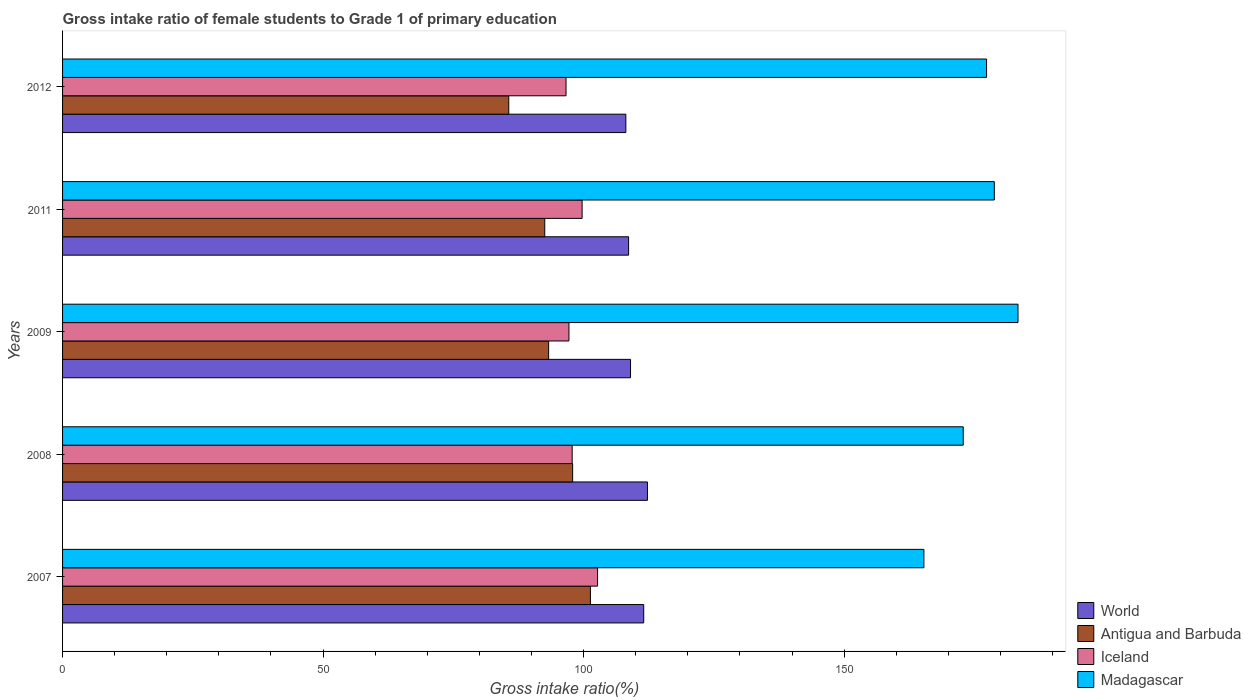How many different coloured bars are there?
Your answer should be very brief. 4. Are the number of bars on each tick of the Y-axis equal?
Make the answer very short. Yes. What is the label of the 4th group of bars from the top?
Your answer should be very brief. 2008. What is the gross intake ratio in World in 2008?
Make the answer very short. 112.26. Across all years, what is the maximum gross intake ratio in Antigua and Barbuda?
Make the answer very short. 101.31. Across all years, what is the minimum gross intake ratio in Antigua and Barbuda?
Keep it short and to the point. 85.64. In which year was the gross intake ratio in Antigua and Barbuda maximum?
Make the answer very short. 2007. In which year was the gross intake ratio in Antigua and Barbuda minimum?
Keep it short and to the point. 2012. What is the total gross intake ratio in World in the graph?
Your response must be concise. 549.55. What is the difference between the gross intake ratio in World in 2007 and that in 2012?
Your response must be concise. 3.43. What is the difference between the gross intake ratio in Antigua and Barbuda in 2009 and the gross intake ratio in Madagascar in 2012?
Your answer should be compact. -84.05. What is the average gross intake ratio in Antigua and Barbuda per year?
Offer a terse response. 94.14. In the year 2007, what is the difference between the gross intake ratio in Antigua and Barbuda and gross intake ratio in Madagascar?
Provide a short and direct response. -64.01. What is the ratio of the gross intake ratio in Madagascar in 2007 to that in 2008?
Your answer should be compact. 0.96. What is the difference between the highest and the second highest gross intake ratio in Antigua and Barbuda?
Your answer should be compact. 3.41. What is the difference between the highest and the lowest gross intake ratio in Madagascar?
Your response must be concise. 18.06. Is the sum of the gross intake ratio in Iceland in 2007 and 2009 greater than the maximum gross intake ratio in Antigua and Barbuda across all years?
Your response must be concise. Yes. Is it the case that in every year, the sum of the gross intake ratio in Antigua and Barbuda and gross intake ratio in Iceland is greater than the sum of gross intake ratio in World and gross intake ratio in Madagascar?
Your answer should be compact. No. What does the 1st bar from the bottom in 2007 represents?
Provide a succinct answer. World. Is it the case that in every year, the sum of the gross intake ratio in Antigua and Barbuda and gross intake ratio in Iceland is greater than the gross intake ratio in World?
Keep it short and to the point. Yes. How many bars are there?
Your response must be concise. 20. What is the difference between two consecutive major ticks on the X-axis?
Offer a very short reply. 50. Are the values on the major ticks of X-axis written in scientific E-notation?
Your answer should be compact. No. How are the legend labels stacked?
Provide a short and direct response. Vertical. What is the title of the graph?
Make the answer very short. Gross intake ratio of female students to Grade 1 of primary education. Does "Brazil" appear as one of the legend labels in the graph?
Your answer should be very brief. No. What is the label or title of the X-axis?
Offer a very short reply. Gross intake ratio(%). What is the Gross intake ratio(%) of World in 2007?
Provide a succinct answer. 111.54. What is the Gross intake ratio(%) of Antigua and Barbuda in 2007?
Offer a very short reply. 101.31. What is the Gross intake ratio(%) in Iceland in 2007?
Give a very brief answer. 102.68. What is the Gross intake ratio(%) of Madagascar in 2007?
Give a very brief answer. 165.32. What is the Gross intake ratio(%) of World in 2008?
Your answer should be compact. 112.26. What is the Gross intake ratio(%) of Antigua and Barbuda in 2008?
Your answer should be very brief. 97.9. What is the Gross intake ratio(%) of Iceland in 2008?
Your answer should be very brief. 97.81. What is the Gross intake ratio(%) in Madagascar in 2008?
Your answer should be compact. 172.86. What is the Gross intake ratio(%) of World in 2009?
Make the answer very short. 109.01. What is the Gross intake ratio(%) in Antigua and Barbuda in 2009?
Offer a terse response. 93.29. What is the Gross intake ratio(%) of Iceland in 2009?
Offer a very short reply. 97.19. What is the Gross intake ratio(%) in Madagascar in 2009?
Offer a very short reply. 183.37. What is the Gross intake ratio(%) of World in 2011?
Your answer should be compact. 108.64. What is the Gross intake ratio(%) in Antigua and Barbuda in 2011?
Ensure brevity in your answer.  92.54. What is the Gross intake ratio(%) in Iceland in 2011?
Your answer should be very brief. 99.71. What is the Gross intake ratio(%) of Madagascar in 2011?
Ensure brevity in your answer.  178.83. What is the Gross intake ratio(%) of World in 2012?
Ensure brevity in your answer.  108.11. What is the Gross intake ratio(%) of Antigua and Barbuda in 2012?
Provide a succinct answer. 85.64. What is the Gross intake ratio(%) in Iceland in 2012?
Ensure brevity in your answer.  96.63. What is the Gross intake ratio(%) of Madagascar in 2012?
Provide a succinct answer. 177.34. Across all years, what is the maximum Gross intake ratio(%) of World?
Provide a succinct answer. 112.26. Across all years, what is the maximum Gross intake ratio(%) of Antigua and Barbuda?
Provide a short and direct response. 101.31. Across all years, what is the maximum Gross intake ratio(%) in Iceland?
Provide a succinct answer. 102.68. Across all years, what is the maximum Gross intake ratio(%) of Madagascar?
Keep it short and to the point. 183.37. Across all years, what is the minimum Gross intake ratio(%) of World?
Your answer should be compact. 108.11. Across all years, what is the minimum Gross intake ratio(%) of Antigua and Barbuda?
Provide a succinct answer. 85.64. Across all years, what is the minimum Gross intake ratio(%) in Iceland?
Provide a succinct answer. 96.63. Across all years, what is the minimum Gross intake ratio(%) of Madagascar?
Give a very brief answer. 165.32. What is the total Gross intake ratio(%) in World in the graph?
Keep it short and to the point. 549.55. What is the total Gross intake ratio(%) in Antigua and Barbuda in the graph?
Give a very brief answer. 470.68. What is the total Gross intake ratio(%) of Iceland in the graph?
Give a very brief answer. 494.01. What is the total Gross intake ratio(%) of Madagascar in the graph?
Offer a very short reply. 877.72. What is the difference between the Gross intake ratio(%) in World in 2007 and that in 2008?
Your response must be concise. -0.72. What is the difference between the Gross intake ratio(%) in Antigua and Barbuda in 2007 and that in 2008?
Provide a succinct answer. 3.41. What is the difference between the Gross intake ratio(%) of Iceland in 2007 and that in 2008?
Give a very brief answer. 4.87. What is the difference between the Gross intake ratio(%) in Madagascar in 2007 and that in 2008?
Offer a very short reply. -7.55. What is the difference between the Gross intake ratio(%) in World in 2007 and that in 2009?
Provide a succinct answer. 2.53. What is the difference between the Gross intake ratio(%) in Antigua and Barbuda in 2007 and that in 2009?
Ensure brevity in your answer.  8.02. What is the difference between the Gross intake ratio(%) in Iceland in 2007 and that in 2009?
Give a very brief answer. 5.49. What is the difference between the Gross intake ratio(%) of Madagascar in 2007 and that in 2009?
Your response must be concise. -18.06. What is the difference between the Gross intake ratio(%) of World in 2007 and that in 2011?
Provide a short and direct response. 2.9. What is the difference between the Gross intake ratio(%) in Antigua and Barbuda in 2007 and that in 2011?
Offer a very short reply. 8.77. What is the difference between the Gross intake ratio(%) of Iceland in 2007 and that in 2011?
Your answer should be compact. 2.96. What is the difference between the Gross intake ratio(%) in Madagascar in 2007 and that in 2011?
Give a very brief answer. -13.51. What is the difference between the Gross intake ratio(%) in World in 2007 and that in 2012?
Your answer should be very brief. 3.43. What is the difference between the Gross intake ratio(%) in Antigua and Barbuda in 2007 and that in 2012?
Give a very brief answer. 15.67. What is the difference between the Gross intake ratio(%) in Iceland in 2007 and that in 2012?
Your answer should be compact. 6.05. What is the difference between the Gross intake ratio(%) of Madagascar in 2007 and that in 2012?
Make the answer very short. -12.02. What is the difference between the Gross intake ratio(%) of World in 2008 and that in 2009?
Keep it short and to the point. 3.25. What is the difference between the Gross intake ratio(%) in Antigua and Barbuda in 2008 and that in 2009?
Your response must be concise. 4.61. What is the difference between the Gross intake ratio(%) in Iceland in 2008 and that in 2009?
Your answer should be compact. 0.62. What is the difference between the Gross intake ratio(%) of Madagascar in 2008 and that in 2009?
Keep it short and to the point. -10.51. What is the difference between the Gross intake ratio(%) in World in 2008 and that in 2011?
Offer a terse response. 3.62. What is the difference between the Gross intake ratio(%) of Antigua and Barbuda in 2008 and that in 2011?
Your response must be concise. 5.35. What is the difference between the Gross intake ratio(%) in Iceland in 2008 and that in 2011?
Give a very brief answer. -1.91. What is the difference between the Gross intake ratio(%) of Madagascar in 2008 and that in 2011?
Offer a terse response. -5.96. What is the difference between the Gross intake ratio(%) of World in 2008 and that in 2012?
Ensure brevity in your answer.  4.15. What is the difference between the Gross intake ratio(%) of Antigua and Barbuda in 2008 and that in 2012?
Make the answer very short. 12.26. What is the difference between the Gross intake ratio(%) of Iceland in 2008 and that in 2012?
Your response must be concise. 1.18. What is the difference between the Gross intake ratio(%) of Madagascar in 2008 and that in 2012?
Offer a terse response. -4.48. What is the difference between the Gross intake ratio(%) of World in 2009 and that in 2011?
Make the answer very short. 0.37. What is the difference between the Gross intake ratio(%) in Antigua and Barbuda in 2009 and that in 2011?
Offer a very short reply. 0.75. What is the difference between the Gross intake ratio(%) of Iceland in 2009 and that in 2011?
Give a very brief answer. -2.53. What is the difference between the Gross intake ratio(%) in Madagascar in 2009 and that in 2011?
Ensure brevity in your answer.  4.55. What is the difference between the Gross intake ratio(%) in World in 2009 and that in 2012?
Ensure brevity in your answer.  0.9. What is the difference between the Gross intake ratio(%) in Antigua and Barbuda in 2009 and that in 2012?
Provide a succinct answer. 7.65. What is the difference between the Gross intake ratio(%) in Iceland in 2009 and that in 2012?
Provide a short and direct response. 0.56. What is the difference between the Gross intake ratio(%) in Madagascar in 2009 and that in 2012?
Ensure brevity in your answer.  6.03. What is the difference between the Gross intake ratio(%) of World in 2011 and that in 2012?
Provide a short and direct response. 0.53. What is the difference between the Gross intake ratio(%) in Antigua and Barbuda in 2011 and that in 2012?
Give a very brief answer. 6.91. What is the difference between the Gross intake ratio(%) in Iceland in 2011 and that in 2012?
Offer a very short reply. 3.09. What is the difference between the Gross intake ratio(%) in Madagascar in 2011 and that in 2012?
Provide a short and direct response. 1.49. What is the difference between the Gross intake ratio(%) of World in 2007 and the Gross intake ratio(%) of Antigua and Barbuda in 2008?
Provide a short and direct response. 13.64. What is the difference between the Gross intake ratio(%) in World in 2007 and the Gross intake ratio(%) in Iceland in 2008?
Keep it short and to the point. 13.73. What is the difference between the Gross intake ratio(%) of World in 2007 and the Gross intake ratio(%) of Madagascar in 2008?
Provide a succinct answer. -61.32. What is the difference between the Gross intake ratio(%) in Antigua and Barbuda in 2007 and the Gross intake ratio(%) in Iceland in 2008?
Ensure brevity in your answer.  3.5. What is the difference between the Gross intake ratio(%) of Antigua and Barbuda in 2007 and the Gross intake ratio(%) of Madagascar in 2008?
Keep it short and to the point. -71.55. What is the difference between the Gross intake ratio(%) in Iceland in 2007 and the Gross intake ratio(%) in Madagascar in 2008?
Make the answer very short. -70.18. What is the difference between the Gross intake ratio(%) of World in 2007 and the Gross intake ratio(%) of Antigua and Barbuda in 2009?
Give a very brief answer. 18.25. What is the difference between the Gross intake ratio(%) in World in 2007 and the Gross intake ratio(%) in Iceland in 2009?
Give a very brief answer. 14.35. What is the difference between the Gross intake ratio(%) in World in 2007 and the Gross intake ratio(%) in Madagascar in 2009?
Your response must be concise. -71.83. What is the difference between the Gross intake ratio(%) in Antigua and Barbuda in 2007 and the Gross intake ratio(%) in Iceland in 2009?
Ensure brevity in your answer.  4.12. What is the difference between the Gross intake ratio(%) of Antigua and Barbuda in 2007 and the Gross intake ratio(%) of Madagascar in 2009?
Your answer should be compact. -82.06. What is the difference between the Gross intake ratio(%) of Iceland in 2007 and the Gross intake ratio(%) of Madagascar in 2009?
Provide a succinct answer. -80.69. What is the difference between the Gross intake ratio(%) of World in 2007 and the Gross intake ratio(%) of Antigua and Barbuda in 2011?
Make the answer very short. 19. What is the difference between the Gross intake ratio(%) in World in 2007 and the Gross intake ratio(%) in Iceland in 2011?
Provide a short and direct response. 11.83. What is the difference between the Gross intake ratio(%) of World in 2007 and the Gross intake ratio(%) of Madagascar in 2011?
Your answer should be compact. -67.29. What is the difference between the Gross intake ratio(%) in Antigua and Barbuda in 2007 and the Gross intake ratio(%) in Iceland in 2011?
Keep it short and to the point. 1.6. What is the difference between the Gross intake ratio(%) in Antigua and Barbuda in 2007 and the Gross intake ratio(%) in Madagascar in 2011?
Offer a very short reply. -77.52. What is the difference between the Gross intake ratio(%) of Iceland in 2007 and the Gross intake ratio(%) of Madagascar in 2011?
Give a very brief answer. -76.15. What is the difference between the Gross intake ratio(%) of World in 2007 and the Gross intake ratio(%) of Antigua and Barbuda in 2012?
Make the answer very short. 25.9. What is the difference between the Gross intake ratio(%) of World in 2007 and the Gross intake ratio(%) of Iceland in 2012?
Ensure brevity in your answer.  14.91. What is the difference between the Gross intake ratio(%) in World in 2007 and the Gross intake ratio(%) in Madagascar in 2012?
Ensure brevity in your answer.  -65.8. What is the difference between the Gross intake ratio(%) of Antigua and Barbuda in 2007 and the Gross intake ratio(%) of Iceland in 2012?
Provide a succinct answer. 4.68. What is the difference between the Gross intake ratio(%) of Antigua and Barbuda in 2007 and the Gross intake ratio(%) of Madagascar in 2012?
Offer a terse response. -76.03. What is the difference between the Gross intake ratio(%) in Iceland in 2007 and the Gross intake ratio(%) in Madagascar in 2012?
Ensure brevity in your answer.  -74.66. What is the difference between the Gross intake ratio(%) in World in 2008 and the Gross intake ratio(%) in Antigua and Barbuda in 2009?
Make the answer very short. 18.97. What is the difference between the Gross intake ratio(%) of World in 2008 and the Gross intake ratio(%) of Iceland in 2009?
Your answer should be very brief. 15.07. What is the difference between the Gross intake ratio(%) in World in 2008 and the Gross intake ratio(%) in Madagascar in 2009?
Make the answer very short. -71.12. What is the difference between the Gross intake ratio(%) in Antigua and Barbuda in 2008 and the Gross intake ratio(%) in Iceland in 2009?
Make the answer very short. 0.71. What is the difference between the Gross intake ratio(%) of Antigua and Barbuda in 2008 and the Gross intake ratio(%) of Madagascar in 2009?
Your response must be concise. -85.48. What is the difference between the Gross intake ratio(%) of Iceland in 2008 and the Gross intake ratio(%) of Madagascar in 2009?
Offer a very short reply. -85.57. What is the difference between the Gross intake ratio(%) in World in 2008 and the Gross intake ratio(%) in Antigua and Barbuda in 2011?
Your answer should be very brief. 19.71. What is the difference between the Gross intake ratio(%) of World in 2008 and the Gross intake ratio(%) of Iceland in 2011?
Give a very brief answer. 12.54. What is the difference between the Gross intake ratio(%) of World in 2008 and the Gross intake ratio(%) of Madagascar in 2011?
Offer a very short reply. -66.57. What is the difference between the Gross intake ratio(%) in Antigua and Barbuda in 2008 and the Gross intake ratio(%) in Iceland in 2011?
Provide a short and direct response. -1.82. What is the difference between the Gross intake ratio(%) of Antigua and Barbuda in 2008 and the Gross intake ratio(%) of Madagascar in 2011?
Provide a succinct answer. -80.93. What is the difference between the Gross intake ratio(%) of Iceland in 2008 and the Gross intake ratio(%) of Madagascar in 2011?
Your answer should be very brief. -81.02. What is the difference between the Gross intake ratio(%) in World in 2008 and the Gross intake ratio(%) in Antigua and Barbuda in 2012?
Give a very brief answer. 26.62. What is the difference between the Gross intake ratio(%) in World in 2008 and the Gross intake ratio(%) in Iceland in 2012?
Your response must be concise. 15.63. What is the difference between the Gross intake ratio(%) in World in 2008 and the Gross intake ratio(%) in Madagascar in 2012?
Offer a terse response. -65.08. What is the difference between the Gross intake ratio(%) in Antigua and Barbuda in 2008 and the Gross intake ratio(%) in Iceland in 2012?
Your answer should be compact. 1.27. What is the difference between the Gross intake ratio(%) of Antigua and Barbuda in 2008 and the Gross intake ratio(%) of Madagascar in 2012?
Your answer should be compact. -79.44. What is the difference between the Gross intake ratio(%) of Iceland in 2008 and the Gross intake ratio(%) of Madagascar in 2012?
Your answer should be very brief. -79.53. What is the difference between the Gross intake ratio(%) in World in 2009 and the Gross intake ratio(%) in Antigua and Barbuda in 2011?
Your answer should be compact. 16.46. What is the difference between the Gross intake ratio(%) of World in 2009 and the Gross intake ratio(%) of Iceland in 2011?
Your answer should be very brief. 9.29. What is the difference between the Gross intake ratio(%) in World in 2009 and the Gross intake ratio(%) in Madagascar in 2011?
Your answer should be very brief. -69.82. What is the difference between the Gross intake ratio(%) in Antigua and Barbuda in 2009 and the Gross intake ratio(%) in Iceland in 2011?
Your answer should be very brief. -6.42. What is the difference between the Gross intake ratio(%) of Antigua and Barbuda in 2009 and the Gross intake ratio(%) of Madagascar in 2011?
Provide a short and direct response. -85.54. What is the difference between the Gross intake ratio(%) of Iceland in 2009 and the Gross intake ratio(%) of Madagascar in 2011?
Offer a terse response. -81.64. What is the difference between the Gross intake ratio(%) in World in 2009 and the Gross intake ratio(%) in Antigua and Barbuda in 2012?
Keep it short and to the point. 23.37. What is the difference between the Gross intake ratio(%) of World in 2009 and the Gross intake ratio(%) of Iceland in 2012?
Your response must be concise. 12.38. What is the difference between the Gross intake ratio(%) of World in 2009 and the Gross intake ratio(%) of Madagascar in 2012?
Your response must be concise. -68.33. What is the difference between the Gross intake ratio(%) in Antigua and Barbuda in 2009 and the Gross intake ratio(%) in Iceland in 2012?
Your answer should be compact. -3.34. What is the difference between the Gross intake ratio(%) of Antigua and Barbuda in 2009 and the Gross intake ratio(%) of Madagascar in 2012?
Your answer should be compact. -84.05. What is the difference between the Gross intake ratio(%) in Iceland in 2009 and the Gross intake ratio(%) in Madagascar in 2012?
Give a very brief answer. -80.15. What is the difference between the Gross intake ratio(%) of World in 2011 and the Gross intake ratio(%) of Antigua and Barbuda in 2012?
Offer a terse response. 23. What is the difference between the Gross intake ratio(%) in World in 2011 and the Gross intake ratio(%) in Iceland in 2012?
Give a very brief answer. 12.01. What is the difference between the Gross intake ratio(%) in World in 2011 and the Gross intake ratio(%) in Madagascar in 2012?
Make the answer very short. -68.7. What is the difference between the Gross intake ratio(%) in Antigua and Barbuda in 2011 and the Gross intake ratio(%) in Iceland in 2012?
Provide a succinct answer. -4.08. What is the difference between the Gross intake ratio(%) of Antigua and Barbuda in 2011 and the Gross intake ratio(%) of Madagascar in 2012?
Ensure brevity in your answer.  -84.8. What is the difference between the Gross intake ratio(%) of Iceland in 2011 and the Gross intake ratio(%) of Madagascar in 2012?
Provide a short and direct response. -77.63. What is the average Gross intake ratio(%) in World per year?
Offer a terse response. 109.91. What is the average Gross intake ratio(%) of Antigua and Barbuda per year?
Make the answer very short. 94.14. What is the average Gross intake ratio(%) of Iceland per year?
Your answer should be compact. 98.8. What is the average Gross intake ratio(%) in Madagascar per year?
Offer a very short reply. 175.54. In the year 2007, what is the difference between the Gross intake ratio(%) of World and Gross intake ratio(%) of Antigua and Barbuda?
Make the answer very short. 10.23. In the year 2007, what is the difference between the Gross intake ratio(%) of World and Gross intake ratio(%) of Iceland?
Your response must be concise. 8.86. In the year 2007, what is the difference between the Gross intake ratio(%) in World and Gross intake ratio(%) in Madagascar?
Make the answer very short. -53.78. In the year 2007, what is the difference between the Gross intake ratio(%) in Antigua and Barbuda and Gross intake ratio(%) in Iceland?
Offer a very short reply. -1.37. In the year 2007, what is the difference between the Gross intake ratio(%) in Antigua and Barbuda and Gross intake ratio(%) in Madagascar?
Keep it short and to the point. -64.01. In the year 2007, what is the difference between the Gross intake ratio(%) of Iceland and Gross intake ratio(%) of Madagascar?
Provide a short and direct response. -62.64. In the year 2008, what is the difference between the Gross intake ratio(%) in World and Gross intake ratio(%) in Antigua and Barbuda?
Your response must be concise. 14.36. In the year 2008, what is the difference between the Gross intake ratio(%) of World and Gross intake ratio(%) of Iceland?
Your response must be concise. 14.45. In the year 2008, what is the difference between the Gross intake ratio(%) in World and Gross intake ratio(%) in Madagascar?
Offer a terse response. -60.61. In the year 2008, what is the difference between the Gross intake ratio(%) in Antigua and Barbuda and Gross intake ratio(%) in Iceland?
Your response must be concise. 0.09. In the year 2008, what is the difference between the Gross intake ratio(%) in Antigua and Barbuda and Gross intake ratio(%) in Madagascar?
Provide a succinct answer. -74.97. In the year 2008, what is the difference between the Gross intake ratio(%) in Iceland and Gross intake ratio(%) in Madagascar?
Give a very brief answer. -75.06. In the year 2009, what is the difference between the Gross intake ratio(%) of World and Gross intake ratio(%) of Antigua and Barbuda?
Offer a terse response. 15.72. In the year 2009, what is the difference between the Gross intake ratio(%) of World and Gross intake ratio(%) of Iceland?
Your response must be concise. 11.82. In the year 2009, what is the difference between the Gross intake ratio(%) of World and Gross intake ratio(%) of Madagascar?
Your answer should be compact. -74.37. In the year 2009, what is the difference between the Gross intake ratio(%) of Antigua and Barbuda and Gross intake ratio(%) of Iceland?
Ensure brevity in your answer.  -3.9. In the year 2009, what is the difference between the Gross intake ratio(%) in Antigua and Barbuda and Gross intake ratio(%) in Madagascar?
Your answer should be compact. -90.08. In the year 2009, what is the difference between the Gross intake ratio(%) in Iceland and Gross intake ratio(%) in Madagascar?
Ensure brevity in your answer.  -86.19. In the year 2011, what is the difference between the Gross intake ratio(%) of World and Gross intake ratio(%) of Antigua and Barbuda?
Make the answer very short. 16.09. In the year 2011, what is the difference between the Gross intake ratio(%) of World and Gross intake ratio(%) of Iceland?
Give a very brief answer. 8.92. In the year 2011, what is the difference between the Gross intake ratio(%) in World and Gross intake ratio(%) in Madagascar?
Keep it short and to the point. -70.19. In the year 2011, what is the difference between the Gross intake ratio(%) of Antigua and Barbuda and Gross intake ratio(%) of Iceland?
Your response must be concise. -7.17. In the year 2011, what is the difference between the Gross intake ratio(%) in Antigua and Barbuda and Gross intake ratio(%) in Madagascar?
Offer a terse response. -86.28. In the year 2011, what is the difference between the Gross intake ratio(%) in Iceland and Gross intake ratio(%) in Madagascar?
Offer a very short reply. -79.11. In the year 2012, what is the difference between the Gross intake ratio(%) of World and Gross intake ratio(%) of Antigua and Barbuda?
Offer a terse response. 22.47. In the year 2012, what is the difference between the Gross intake ratio(%) of World and Gross intake ratio(%) of Iceland?
Your answer should be compact. 11.48. In the year 2012, what is the difference between the Gross intake ratio(%) in World and Gross intake ratio(%) in Madagascar?
Your answer should be compact. -69.23. In the year 2012, what is the difference between the Gross intake ratio(%) in Antigua and Barbuda and Gross intake ratio(%) in Iceland?
Give a very brief answer. -10.99. In the year 2012, what is the difference between the Gross intake ratio(%) of Antigua and Barbuda and Gross intake ratio(%) of Madagascar?
Provide a succinct answer. -91.7. In the year 2012, what is the difference between the Gross intake ratio(%) in Iceland and Gross intake ratio(%) in Madagascar?
Offer a terse response. -80.71. What is the ratio of the Gross intake ratio(%) in World in 2007 to that in 2008?
Make the answer very short. 0.99. What is the ratio of the Gross intake ratio(%) in Antigua and Barbuda in 2007 to that in 2008?
Your response must be concise. 1.03. What is the ratio of the Gross intake ratio(%) of Iceland in 2007 to that in 2008?
Ensure brevity in your answer.  1.05. What is the ratio of the Gross intake ratio(%) of Madagascar in 2007 to that in 2008?
Your answer should be compact. 0.96. What is the ratio of the Gross intake ratio(%) of World in 2007 to that in 2009?
Your answer should be compact. 1.02. What is the ratio of the Gross intake ratio(%) of Antigua and Barbuda in 2007 to that in 2009?
Offer a very short reply. 1.09. What is the ratio of the Gross intake ratio(%) in Iceland in 2007 to that in 2009?
Keep it short and to the point. 1.06. What is the ratio of the Gross intake ratio(%) in Madagascar in 2007 to that in 2009?
Your response must be concise. 0.9. What is the ratio of the Gross intake ratio(%) of World in 2007 to that in 2011?
Offer a terse response. 1.03. What is the ratio of the Gross intake ratio(%) in Antigua and Barbuda in 2007 to that in 2011?
Your response must be concise. 1.09. What is the ratio of the Gross intake ratio(%) of Iceland in 2007 to that in 2011?
Make the answer very short. 1.03. What is the ratio of the Gross intake ratio(%) of Madagascar in 2007 to that in 2011?
Provide a short and direct response. 0.92. What is the ratio of the Gross intake ratio(%) of World in 2007 to that in 2012?
Your response must be concise. 1.03. What is the ratio of the Gross intake ratio(%) in Antigua and Barbuda in 2007 to that in 2012?
Offer a very short reply. 1.18. What is the ratio of the Gross intake ratio(%) in Iceland in 2007 to that in 2012?
Ensure brevity in your answer.  1.06. What is the ratio of the Gross intake ratio(%) of Madagascar in 2007 to that in 2012?
Provide a succinct answer. 0.93. What is the ratio of the Gross intake ratio(%) of World in 2008 to that in 2009?
Your response must be concise. 1.03. What is the ratio of the Gross intake ratio(%) in Antigua and Barbuda in 2008 to that in 2009?
Your response must be concise. 1.05. What is the ratio of the Gross intake ratio(%) in Iceland in 2008 to that in 2009?
Give a very brief answer. 1.01. What is the ratio of the Gross intake ratio(%) in Madagascar in 2008 to that in 2009?
Provide a succinct answer. 0.94. What is the ratio of the Gross intake ratio(%) in Antigua and Barbuda in 2008 to that in 2011?
Offer a very short reply. 1.06. What is the ratio of the Gross intake ratio(%) of Iceland in 2008 to that in 2011?
Offer a terse response. 0.98. What is the ratio of the Gross intake ratio(%) in Madagascar in 2008 to that in 2011?
Keep it short and to the point. 0.97. What is the ratio of the Gross intake ratio(%) in World in 2008 to that in 2012?
Provide a succinct answer. 1.04. What is the ratio of the Gross intake ratio(%) of Antigua and Barbuda in 2008 to that in 2012?
Make the answer very short. 1.14. What is the ratio of the Gross intake ratio(%) of Iceland in 2008 to that in 2012?
Make the answer very short. 1.01. What is the ratio of the Gross intake ratio(%) in Madagascar in 2008 to that in 2012?
Offer a terse response. 0.97. What is the ratio of the Gross intake ratio(%) of World in 2009 to that in 2011?
Make the answer very short. 1. What is the ratio of the Gross intake ratio(%) of Iceland in 2009 to that in 2011?
Make the answer very short. 0.97. What is the ratio of the Gross intake ratio(%) in Madagascar in 2009 to that in 2011?
Offer a very short reply. 1.03. What is the ratio of the Gross intake ratio(%) in World in 2009 to that in 2012?
Keep it short and to the point. 1.01. What is the ratio of the Gross intake ratio(%) in Antigua and Barbuda in 2009 to that in 2012?
Ensure brevity in your answer.  1.09. What is the ratio of the Gross intake ratio(%) of Iceland in 2009 to that in 2012?
Offer a terse response. 1.01. What is the ratio of the Gross intake ratio(%) of Madagascar in 2009 to that in 2012?
Your answer should be compact. 1.03. What is the ratio of the Gross intake ratio(%) of Antigua and Barbuda in 2011 to that in 2012?
Your answer should be compact. 1.08. What is the ratio of the Gross intake ratio(%) in Iceland in 2011 to that in 2012?
Your answer should be very brief. 1.03. What is the ratio of the Gross intake ratio(%) in Madagascar in 2011 to that in 2012?
Your response must be concise. 1.01. What is the difference between the highest and the second highest Gross intake ratio(%) of World?
Offer a very short reply. 0.72. What is the difference between the highest and the second highest Gross intake ratio(%) of Antigua and Barbuda?
Offer a very short reply. 3.41. What is the difference between the highest and the second highest Gross intake ratio(%) in Iceland?
Your answer should be compact. 2.96. What is the difference between the highest and the second highest Gross intake ratio(%) in Madagascar?
Your answer should be compact. 4.55. What is the difference between the highest and the lowest Gross intake ratio(%) in World?
Make the answer very short. 4.15. What is the difference between the highest and the lowest Gross intake ratio(%) in Antigua and Barbuda?
Offer a very short reply. 15.67. What is the difference between the highest and the lowest Gross intake ratio(%) of Iceland?
Provide a succinct answer. 6.05. What is the difference between the highest and the lowest Gross intake ratio(%) in Madagascar?
Give a very brief answer. 18.06. 